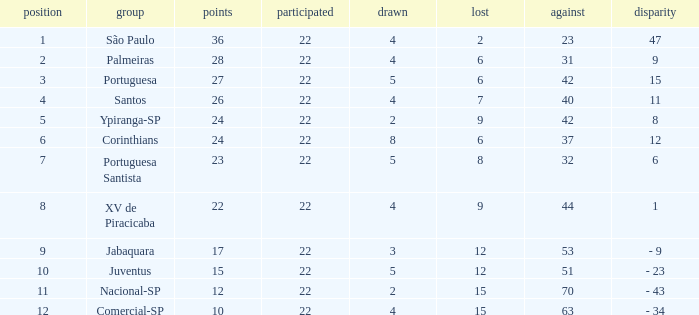Which Played has a Lost larger than 9, and a Points smaller than 15, and a Position smaller than 12, and a Drawn smaller than 2? None. Would you mind parsing the complete table? {'header': ['position', 'group', 'points', 'participated', 'drawn', 'lost', 'against', 'disparity'], 'rows': [['1', 'São Paulo', '36', '22', '4', '2', '23', '47'], ['2', 'Palmeiras', '28', '22', '4', '6', '31', '9'], ['3', 'Portuguesa', '27', '22', '5', '6', '42', '15'], ['4', 'Santos', '26', '22', '4', '7', '40', '11'], ['5', 'Ypiranga-SP', '24', '22', '2', '9', '42', '8'], ['6', 'Corinthians', '24', '22', '8', '6', '37', '12'], ['7', 'Portuguesa Santista', '23', '22', '5', '8', '32', '6'], ['8', 'XV de Piracicaba', '22', '22', '4', '9', '44', '1'], ['9', 'Jabaquara', '17', '22', '3', '12', '53', '- 9'], ['10', 'Juventus', '15', '22', '5', '12', '51', '- 23'], ['11', 'Nacional-SP', '12', '22', '2', '15', '70', '- 43'], ['12', 'Comercial-SP', '10', '22', '4', '15', '63', '- 34']]} 